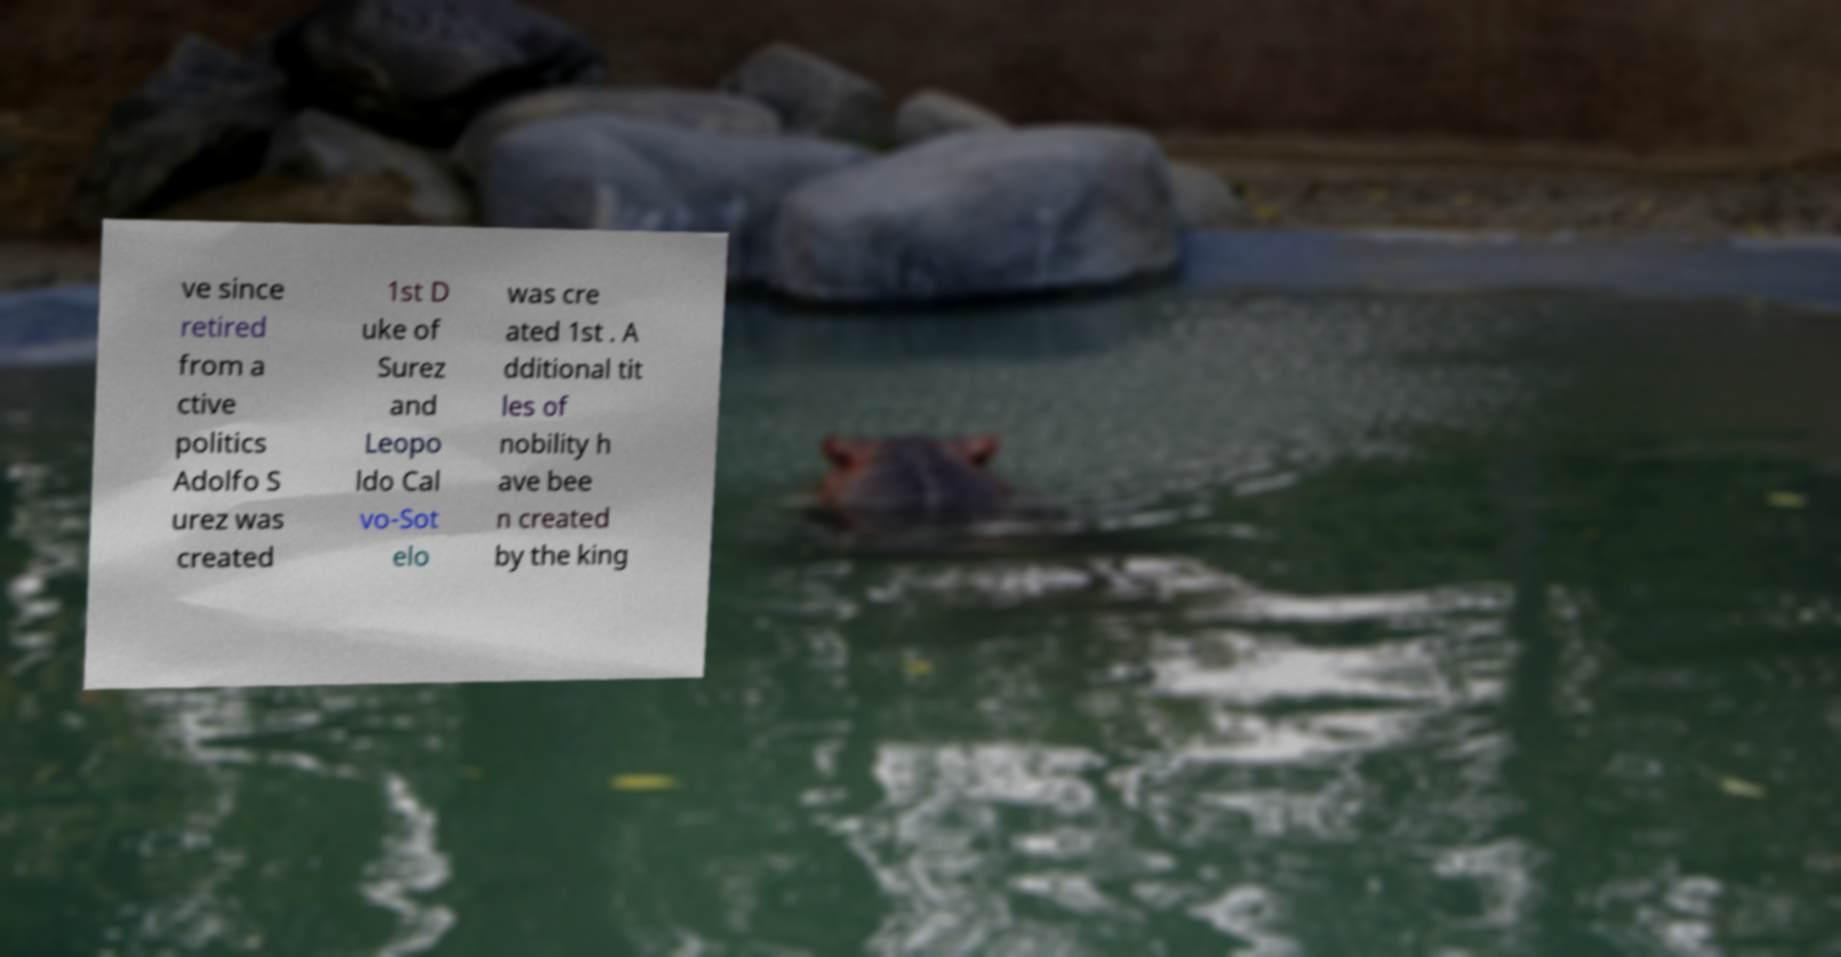There's text embedded in this image that I need extracted. Can you transcribe it verbatim? ve since retired from a ctive politics Adolfo S urez was created 1st D uke of Surez and Leopo ldo Cal vo-Sot elo was cre ated 1st . A dditional tit les of nobility h ave bee n created by the king 